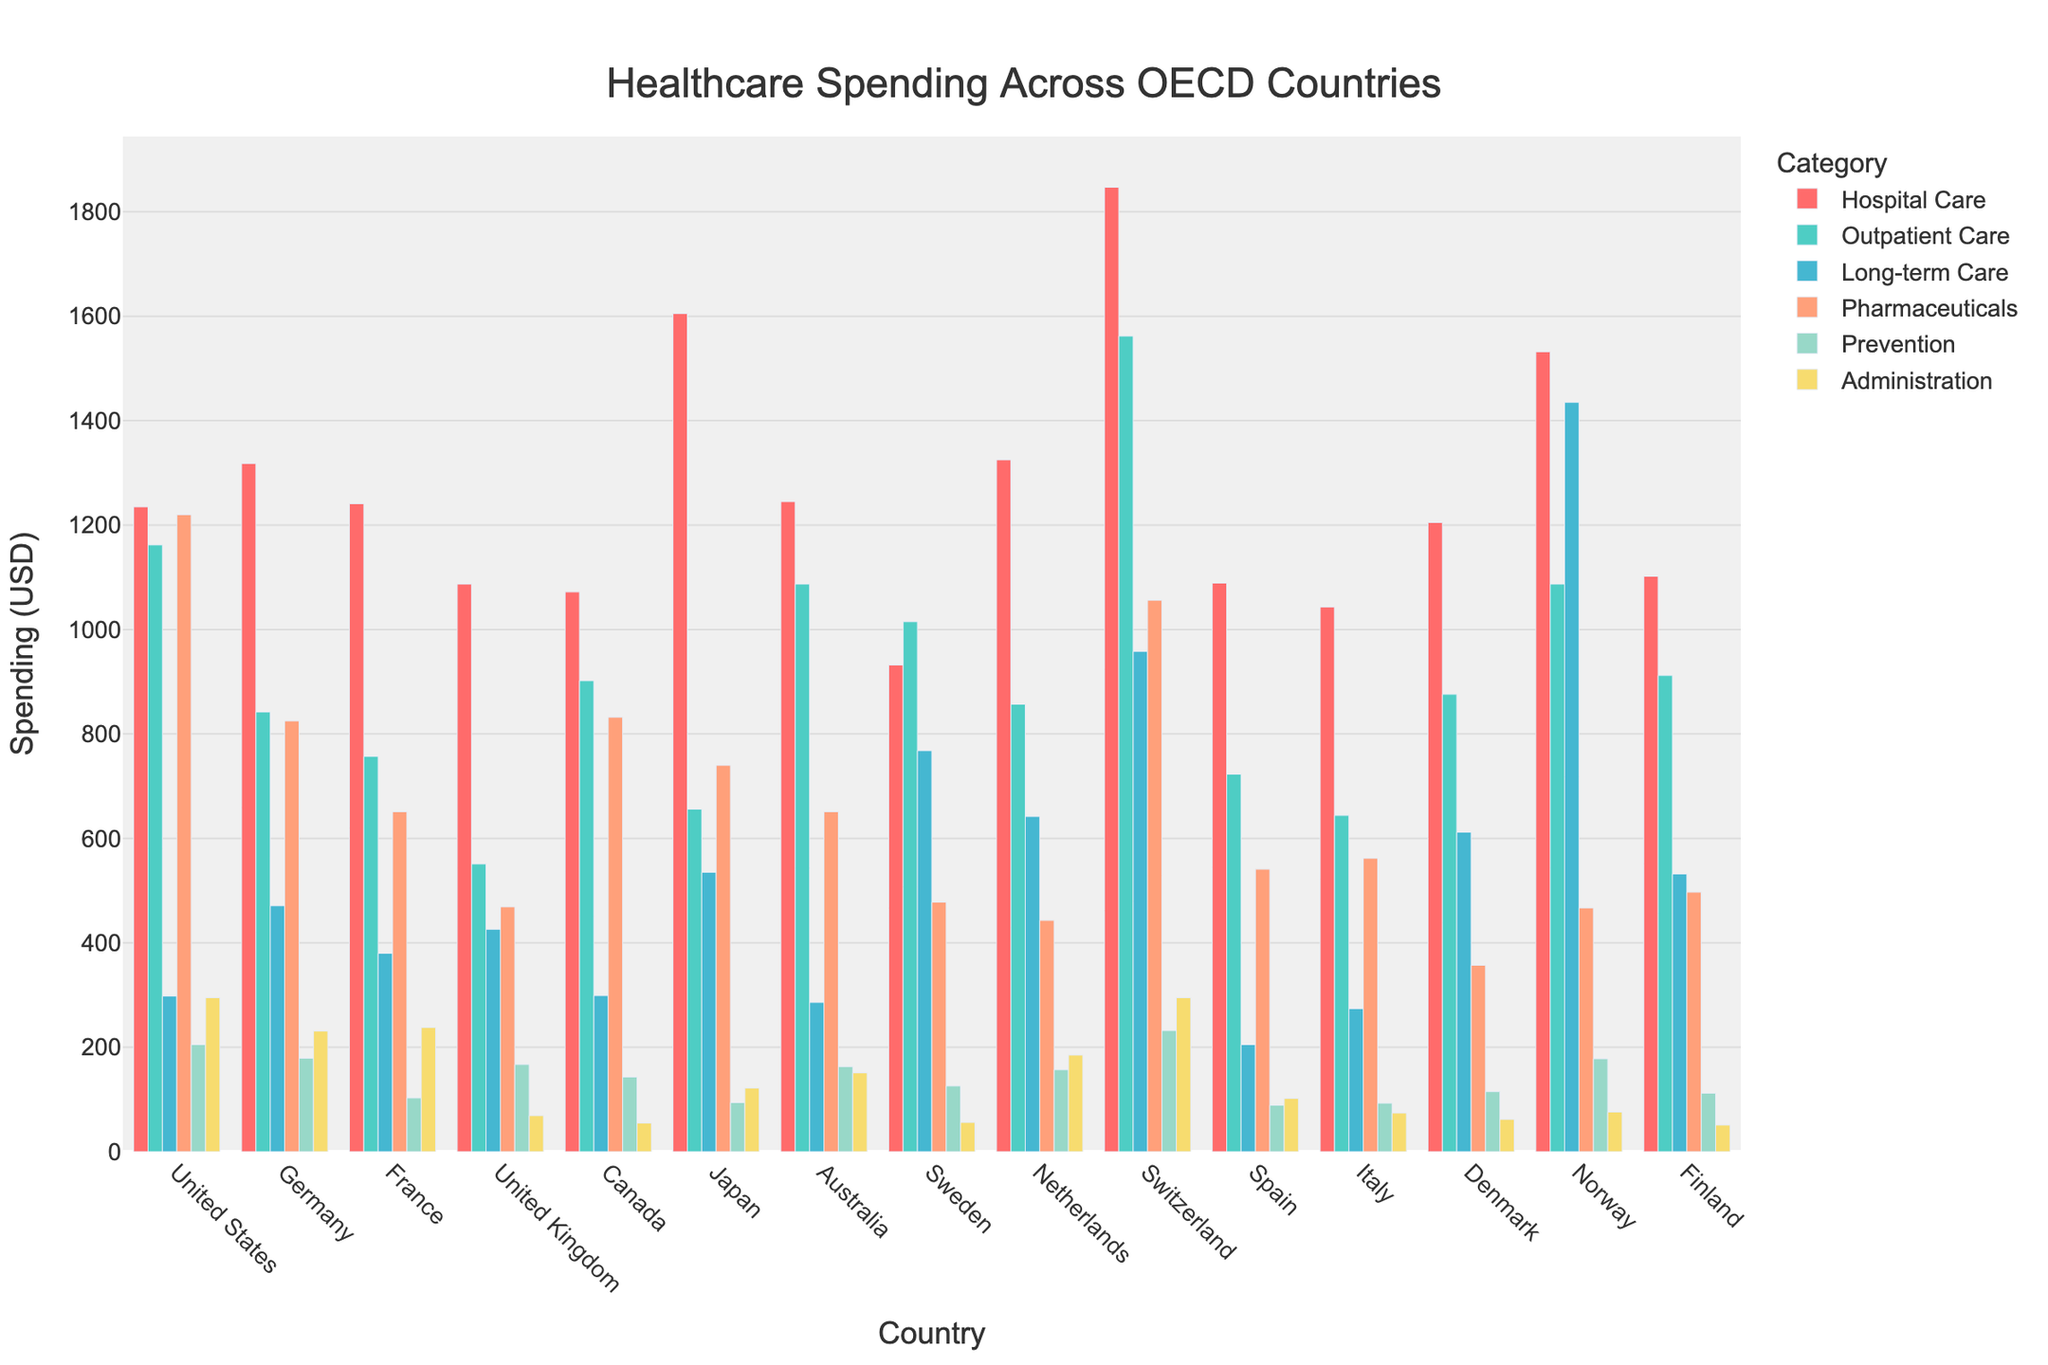Which country has the highest overall healthcare spending in hospital care? Look at the bar for "Hospital Care" and compare the heights across different countries. Switzerland has the tallest bar for hospital care.
Answer: Switzerland Which country spends the least on pharmaceuticals? Compare the height of the bars representing "Pharmaceuticals" expenditure across all countries. Spain has the shortest bar.
Answer: Spain What's the total healthcare spending for Japan by adding all major expenditure categories? Sum the values of all spending categories for Japan: 1605 + 656 + 535 + 740 + 94 + 122 = 3752.
Answer: 3752 How does the spending on hospital care in the United Kingdom compare with that in Sweden? Compare the heights of the "Hospital Care" bars for the United Kingdom and Sweden. The bar for the United Kingdom is taller than the bar for Sweden.
Answer: The United Kingdom spends more on hospital care Which two countries have the closest spending in outpatient care? Look at the "Outpatient Care" bars and identify two bars that are closest in height. Australia and Norway have similar heights for outpatient care.
Answer: Australia and Norway Which expenditure category has the highest spending in the United States? Look at the bars for the United States and identify the category with the tallest bar. The tallest bar for the United States is "Hospital Care".
Answer: Hospital Care Compare the spending on long-term care in Norway and the Netherlands. How much more (or less) does Norway spend than the Netherlands? Identify the bars for "Long-term Care" for both countries. Norway spends 1435, and the Netherlands spends 642. The difference is 1435 - 642 = 793.
Answer: Norway spends 793 more What's the average spending on outpatient care across all countries? Sum the "Outpatient Care" values for all countries and divide by the number of countries: (1162 + 842 + 757 + 551 + 902 + 656 + 1087 + 1015 + 857 + 1562 + 723 + 644 + 876 + 1087 + 912) / 15 = 892.
Answer: 892 Which country has the lowest spending on administration? Compare the heights of the bars representing "Administration" expenditure. Finland has the shortest bar.
Answer: Finland 